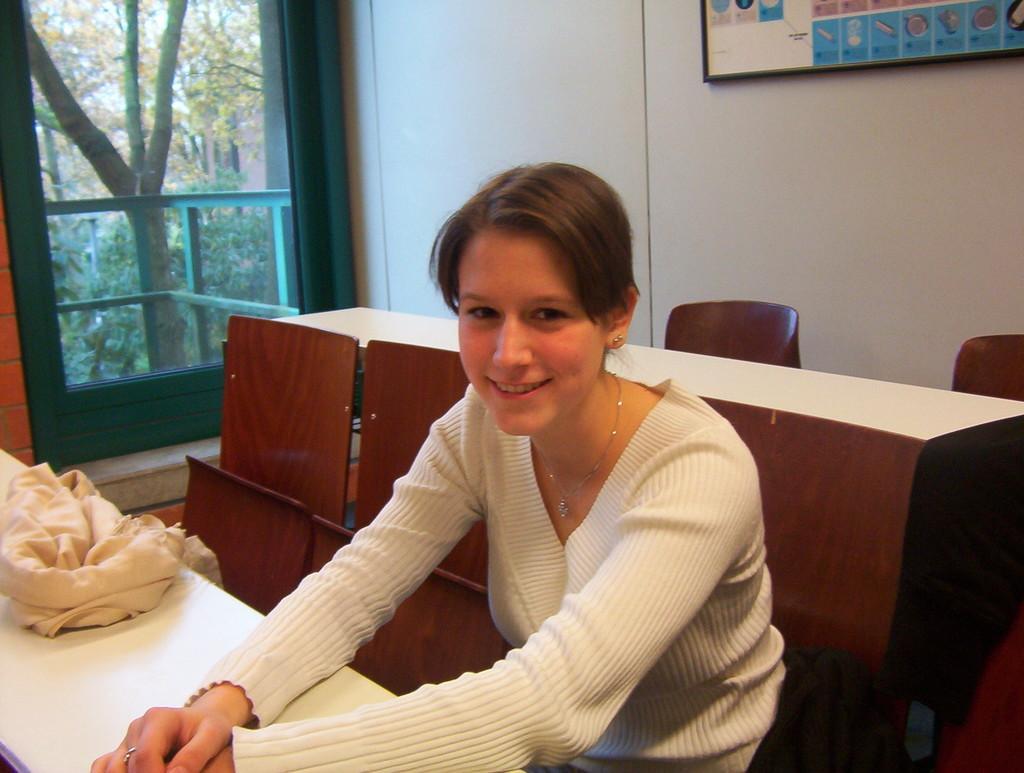Please provide a concise description of this image. In the image there is a woman she is sitting on the chair and posing for the photo,in the left side there is a window and beside the window there is a wall and some poster is attached to the wall. 